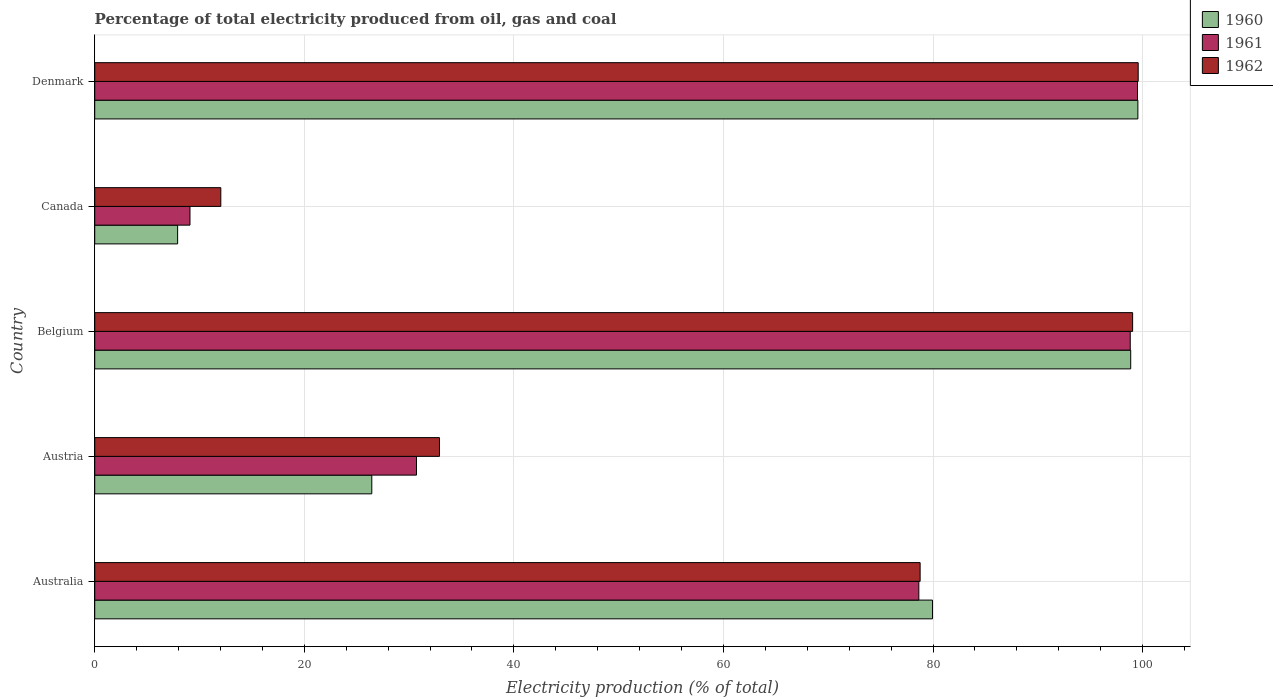How many different coloured bars are there?
Keep it short and to the point. 3. Are the number of bars per tick equal to the number of legend labels?
Provide a succinct answer. Yes. How many bars are there on the 3rd tick from the bottom?
Offer a very short reply. 3. What is the label of the 2nd group of bars from the top?
Provide a succinct answer. Canada. In how many cases, is the number of bars for a given country not equal to the number of legend labels?
Ensure brevity in your answer.  0. What is the electricity production in in 1961 in Belgium?
Provide a short and direct response. 98.82. Across all countries, what is the maximum electricity production in in 1962?
Provide a short and direct response. 99.58. Across all countries, what is the minimum electricity production in in 1962?
Offer a very short reply. 12.03. What is the total electricity production in in 1961 in the graph?
Provide a short and direct response. 316.77. What is the difference between the electricity production in in 1960 in Australia and that in Belgium?
Ensure brevity in your answer.  -18.92. What is the difference between the electricity production in in 1962 in Canada and the electricity production in in 1961 in Belgium?
Ensure brevity in your answer.  -86.79. What is the average electricity production in in 1962 per country?
Your answer should be very brief. 64.47. What is the difference between the electricity production in in 1961 and electricity production in in 1962 in Denmark?
Ensure brevity in your answer.  -0.07. What is the ratio of the electricity production in in 1961 in Australia to that in Austria?
Offer a very short reply. 2.56. Is the difference between the electricity production in in 1961 in Austria and Canada greater than the difference between the electricity production in in 1962 in Austria and Canada?
Provide a short and direct response. Yes. What is the difference between the highest and the second highest electricity production in in 1961?
Offer a terse response. 0.69. What is the difference between the highest and the lowest electricity production in in 1962?
Your answer should be compact. 87.55. What does the 1st bar from the top in Denmark represents?
Keep it short and to the point. 1962. How many bars are there?
Offer a terse response. 15. Are all the bars in the graph horizontal?
Your response must be concise. Yes. How many countries are there in the graph?
Your answer should be compact. 5. What is the difference between two consecutive major ticks on the X-axis?
Give a very brief answer. 20. Are the values on the major ticks of X-axis written in scientific E-notation?
Offer a very short reply. No. Does the graph contain grids?
Offer a very short reply. Yes. How many legend labels are there?
Ensure brevity in your answer.  3. How are the legend labels stacked?
Provide a succinct answer. Vertical. What is the title of the graph?
Your answer should be compact. Percentage of total electricity produced from oil, gas and coal. Does "1991" appear as one of the legend labels in the graph?
Offer a terse response. No. What is the label or title of the X-axis?
Keep it short and to the point. Electricity production (% of total). What is the Electricity production (% of total) in 1960 in Australia?
Offer a terse response. 79.95. What is the Electricity production (% of total) of 1961 in Australia?
Offer a very short reply. 78.65. What is the Electricity production (% of total) of 1962 in Australia?
Make the answer very short. 78.77. What is the Electricity production (% of total) of 1960 in Austria?
Offer a terse response. 26.44. What is the Electricity production (% of total) of 1961 in Austria?
Your answer should be very brief. 30.71. What is the Electricity production (% of total) in 1962 in Austria?
Provide a succinct answer. 32.9. What is the Electricity production (% of total) of 1960 in Belgium?
Your response must be concise. 98.86. What is the Electricity production (% of total) of 1961 in Belgium?
Your response must be concise. 98.82. What is the Electricity production (% of total) in 1962 in Belgium?
Offer a terse response. 99.05. What is the Electricity production (% of total) of 1960 in Canada?
Your answer should be compact. 7.91. What is the Electricity production (% of total) in 1961 in Canada?
Your answer should be very brief. 9.09. What is the Electricity production (% of total) of 1962 in Canada?
Your answer should be very brief. 12.03. What is the Electricity production (% of total) of 1960 in Denmark?
Provide a short and direct response. 99.55. What is the Electricity production (% of total) in 1961 in Denmark?
Offer a terse response. 99.51. What is the Electricity production (% of total) in 1962 in Denmark?
Give a very brief answer. 99.58. Across all countries, what is the maximum Electricity production (% of total) in 1960?
Offer a very short reply. 99.55. Across all countries, what is the maximum Electricity production (% of total) in 1961?
Give a very brief answer. 99.51. Across all countries, what is the maximum Electricity production (% of total) of 1962?
Your answer should be compact. 99.58. Across all countries, what is the minimum Electricity production (% of total) in 1960?
Your answer should be compact. 7.91. Across all countries, what is the minimum Electricity production (% of total) of 1961?
Offer a very short reply. 9.09. Across all countries, what is the minimum Electricity production (% of total) of 1962?
Make the answer very short. 12.03. What is the total Electricity production (% of total) of 1960 in the graph?
Your answer should be compact. 312.71. What is the total Electricity production (% of total) of 1961 in the graph?
Provide a succinct answer. 316.77. What is the total Electricity production (% of total) of 1962 in the graph?
Provide a short and direct response. 322.33. What is the difference between the Electricity production (% of total) of 1960 in Australia and that in Austria?
Offer a very short reply. 53.51. What is the difference between the Electricity production (% of total) of 1961 in Australia and that in Austria?
Provide a short and direct response. 47.94. What is the difference between the Electricity production (% of total) in 1962 in Australia and that in Austria?
Your answer should be very brief. 45.87. What is the difference between the Electricity production (% of total) in 1960 in Australia and that in Belgium?
Provide a short and direct response. -18.92. What is the difference between the Electricity production (% of total) of 1961 in Australia and that in Belgium?
Your answer should be very brief. -20.18. What is the difference between the Electricity production (% of total) of 1962 in Australia and that in Belgium?
Provide a succinct answer. -20.28. What is the difference between the Electricity production (% of total) in 1960 in Australia and that in Canada?
Ensure brevity in your answer.  72.04. What is the difference between the Electricity production (% of total) in 1961 in Australia and that in Canada?
Offer a very short reply. 69.56. What is the difference between the Electricity production (% of total) in 1962 in Australia and that in Canada?
Keep it short and to the point. 66.74. What is the difference between the Electricity production (% of total) of 1960 in Australia and that in Denmark?
Provide a succinct answer. -19.6. What is the difference between the Electricity production (% of total) of 1961 in Australia and that in Denmark?
Your answer should be compact. -20.87. What is the difference between the Electricity production (% of total) of 1962 in Australia and that in Denmark?
Offer a terse response. -20.81. What is the difference between the Electricity production (% of total) of 1960 in Austria and that in Belgium?
Offer a terse response. -72.42. What is the difference between the Electricity production (% of total) of 1961 in Austria and that in Belgium?
Give a very brief answer. -68.11. What is the difference between the Electricity production (% of total) of 1962 in Austria and that in Belgium?
Your answer should be very brief. -66.15. What is the difference between the Electricity production (% of total) in 1960 in Austria and that in Canada?
Make the answer very short. 18.53. What is the difference between the Electricity production (% of total) of 1961 in Austria and that in Canada?
Your response must be concise. 21.62. What is the difference between the Electricity production (% of total) in 1962 in Austria and that in Canada?
Your answer should be very brief. 20.87. What is the difference between the Electricity production (% of total) of 1960 in Austria and that in Denmark?
Your answer should be compact. -73.11. What is the difference between the Electricity production (% of total) in 1961 in Austria and that in Denmark?
Offer a terse response. -68.8. What is the difference between the Electricity production (% of total) of 1962 in Austria and that in Denmark?
Keep it short and to the point. -66.68. What is the difference between the Electricity production (% of total) in 1960 in Belgium and that in Canada?
Offer a very short reply. 90.95. What is the difference between the Electricity production (% of total) in 1961 in Belgium and that in Canada?
Keep it short and to the point. 89.73. What is the difference between the Electricity production (% of total) in 1962 in Belgium and that in Canada?
Keep it short and to the point. 87.02. What is the difference between the Electricity production (% of total) of 1960 in Belgium and that in Denmark?
Ensure brevity in your answer.  -0.68. What is the difference between the Electricity production (% of total) in 1961 in Belgium and that in Denmark?
Your response must be concise. -0.69. What is the difference between the Electricity production (% of total) of 1962 in Belgium and that in Denmark?
Offer a terse response. -0.53. What is the difference between the Electricity production (% of total) in 1960 in Canada and that in Denmark?
Make the answer very short. -91.64. What is the difference between the Electricity production (% of total) in 1961 in Canada and that in Denmark?
Offer a very short reply. -90.42. What is the difference between the Electricity production (% of total) in 1962 in Canada and that in Denmark?
Offer a very short reply. -87.55. What is the difference between the Electricity production (% of total) of 1960 in Australia and the Electricity production (% of total) of 1961 in Austria?
Your answer should be very brief. 49.24. What is the difference between the Electricity production (% of total) in 1960 in Australia and the Electricity production (% of total) in 1962 in Austria?
Offer a terse response. 47.05. What is the difference between the Electricity production (% of total) of 1961 in Australia and the Electricity production (% of total) of 1962 in Austria?
Provide a succinct answer. 45.74. What is the difference between the Electricity production (% of total) of 1960 in Australia and the Electricity production (% of total) of 1961 in Belgium?
Your answer should be compact. -18.87. What is the difference between the Electricity production (% of total) in 1960 in Australia and the Electricity production (% of total) in 1962 in Belgium?
Provide a succinct answer. -19.1. What is the difference between the Electricity production (% of total) of 1961 in Australia and the Electricity production (% of total) of 1962 in Belgium?
Make the answer very short. -20.4. What is the difference between the Electricity production (% of total) in 1960 in Australia and the Electricity production (% of total) in 1961 in Canada?
Offer a very short reply. 70.86. What is the difference between the Electricity production (% of total) in 1960 in Australia and the Electricity production (% of total) in 1962 in Canada?
Give a very brief answer. 67.92. What is the difference between the Electricity production (% of total) of 1961 in Australia and the Electricity production (% of total) of 1962 in Canada?
Your answer should be very brief. 66.61. What is the difference between the Electricity production (% of total) of 1960 in Australia and the Electricity production (% of total) of 1961 in Denmark?
Your answer should be very brief. -19.56. What is the difference between the Electricity production (% of total) in 1960 in Australia and the Electricity production (% of total) in 1962 in Denmark?
Give a very brief answer. -19.63. What is the difference between the Electricity production (% of total) of 1961 in Australia and the Electricity production (% of total) of 1962 in Denmark?
Your answer should be very brief. -20.93. What is the difference between the Electricity production (% of total) of 1960 in Austria and the Electricity production (% of total) of 1961 in Belgium?
Ensure brevity in your answer.  -72.38. What is the difference between the Electricity production (% of total) of 1960 in Austria and the Electricity production (% of total) of 1962 in Belgium?
Your answer should be compact. -72.61. What is the difference between the Electricity production (% of total) in 1961 in Austria and the Electricity production (% of total) in 1962 in Belgium?
Provide a succinct answer. -68.34. What is the difference between the Electricity production (% of total) in 1960 in Austria and the Electricity production (% of total) in 1961 in Canada?
Keep it short and to the point. 17.35. What is the difference between the Electricity production (% of total) of 1960 in Austria and the Electricity production (% of total) of 1962 in Canada?
Ensure brevity in your answer.  14.41. What is the difference between the Electricity production (% of total) in 1961 in Austria and the Electricity production (% of total) in 1962 in Canada?
Give a very brief answer. 18.67. What is the difference between the Electricity production (% of total) in 1960 in Austria and the Electricity production (% of total) in 1961 in Denmark?
Make the answer very short. -73.07. What is the difference between the Electricity production (% of total) of 1960 in Austria and the Electricity production (% of total) of 1962 in Denmark?
Your answer should be very brief. -73.14. What is the difference between the Electricity production (% of total) in 1961 in Austria and the Electricity production (% of total) in 1962 in Denmark?
Your response must be concise. -68.87. What is the difference between the Electricity production (% of total) of 1960 in Belgium and the Electricity production (% of total) of 1961 in Canada?
Provide a short and direct response. 89.78. What is the difference between the Electricity production (% of total) of 1960 in Belgium and the Electricity production (% of total) of 1962 in Canada?
Make the answer very short. 86.83. What is the difference between the Electricity production (% of total) in 1961 in Belgium and the Electricity production (% of total) in 1962 in Canada?
Give a very brief answer. 86.79. What is the difference between the Electricity production (% of total) of 1960 in Belgium and the Electricity production (% of total) of 1961 in Denmark?
Provide a short and direct response. -0.65. What is the difference between the Electricity production (% of total) in 1960 in Belgium and the Electricity production (% of total) in 1962 in Denmark?
Give a very brief answer. -0.71. What is the difference between the Electricity production (% of total) in 1961 in Belgium and the Electricity production (% of total) in 1962 in Denmark?
Give a very brief answer. -0.76. What is the difference between the Electricity production (% of total) in 1960 in Canada and the Electricity production (% of total) in 1961 in Denmark?
Ensure brevity in your answer.  -91.6. What is the difference between the Electricity production (% of total) in 1960 in Canada and the Electricity production (% of total) in 1962 in Denmark?
Provide a short and direct response. -91.67. What is the difference between the Electricity production (% of total) of 1961 in Canada and the Electricity production (% of total) of 1962 in Denmark?
Provide a succinct answer. -90.49. What is the average Electricity production (% of total) in 1960 per country?
Your response must be concise. 62.54. What is the average Electricity production (% of total) in 1961 per country?
Provide a short and direct response. 63.35. What is the average Electricity production (% of total) of 1962 per country?
Offer a terse response. 64.47. What is the difference between the Electricity production (% of total) in 1960 and Electricity production (% of total) in 1961 in Australia?
Provide a succinct answer. 1.3. What is the difference between the Electricity production (% of total) in 1960 and Electricity production (% of total) in 1962 in Australia?
Provide a short and direct response. 1.18. What is the difference between the Electricity production (% of total) of 1961 and Electricity production (% of total) of 1962 in Australia?
Ensure brevity in your answer.  -0.12. What is the difference between the Electricity production (% of total) in 1960 and Electricity production (% of total) in 1961 in Austria?
Provide a succinct answer. -4.27. What is the difference between the Electricity production (% of total) in 1960 and Electricity production (% of total) in 1962 in Austria?
Keep it short and to the point. -6.46. What is the difference between the Electricity production (% of total) in 1961 and Electricity production (% of total) in 1962 in Austria?
Your response must be concise. -2.19. What is the difference between the Electricity production (% of total) of 1960 and Electricity production (% of total) of 1961 in Belgium?
Offer a terse response. 0.04. What is the difference between the Electricity production (% of total) of 1960 and Electricity production (% of total) of 1962 in Belgium?
Ensure brevity in your answer.  -0.18. What is the difference between the Electricity production (% of total) in 1961 and Electricity production (% of total) in 1962 in Belgium?
Provide a succinct answer. -0.23. What is the difference between the Electricity production (% of total) of 1960 and Electricity production (% of total) of 1961 in Canada?
Your response must be concise. -1.18. What is the difference between the Electricity production (% of total) in 1960 and Electricity production (% of total) in 1962 in Canada?
Provide a short and direct response. -4.12. What is the difference between the Electricity production (% of total) of 1961 and Electricity production (% of total) of 1962 in Canada?
Your answer should be compact. -2.94. What is the difference between the Electricity production (% of total) of 1960 and Electricity production (% of total) of 1961 in Denmark?
Offer a terse response. 0.04. What is the difference between the Electricity production (% of total) of 1960 and Electricity production (% of total) of 1962 in Denmark?
Provide a short and direct response. -0.03. What is the difference between the Electricity production (% of total) in 1961 and Electricity production (% of total) in 1962 in Denmark?
Provide a short and direct response. -0.07. What is the ratio of the Electricity production (% of total) in 1960 in Australia to that in Austria?
Offer a very short reply. 3.02. What is the ratio of the Electricity production (% of total) in 1961 in Australia to that in Austria?
Offer a terse response. 2.56. What is the ratio of the Electricity production (% of total) of 1962 in Australia to that in Austria?
Your answer should be very brief. 2.39. What is the ratio of the Electricity production (% of total) of 1960 in Australia to that in Belgium?
Make the answer very short. 0.81. What is the ratio of the Electricity production (% of total) of 1961 in Australia to that in Belgium?
Provide a short and direct response. 0.8. What is the ratio of the Electricity production (% of total) of 1962 in Australia to that in Belgium?
Your answer should be very brief. 0.8. What is the ratio of the Electricity production (% of total) in 1960 in Australia to that in Canada?
Provide a short and direct response. 10.11. What is the ratio of the Electricity production (% of total) in 1961 in Australia to that in Canada?
Give a very brief answer. 8.65. What is the ratio of the Electricity production (% of total) in 1962 in Australia to that in Canada?
Your answer should be very brief. 6.55. What is the ratio of the Electricity production (% of total) of 1960 in Australia to that in Denmark?
Keep it short and to the point. 0.8. What is the ratio of the Electricity production (% of total) of 1961 in Australia to that in Denmark?
Your response must be concise. 0.79. What is the ratio of the Electricity production (% of total) of 1962 in Australia to that in Denmark?
Ensure brevity in your answer.  0.79. What is the ratio of the Electricity production (% of total) in 1960 in Austria to that in Belgium?
Ensure brevity in your answer.  0.27. What is the ratio of the Electricity production (% of total) in 1961 in Austria to that in Belgium?
Offer a terse response. 0.31. What is the ratio of the Electricity production (% of total) in 1962 in Austria to that in Belgium?
Offer a very short reply. 0.33. What is the ratio of the Electricity production (% of total) in 1960 in Austria to that in Canada?
Your answer should be very brief. 3.34. What is the ratio of the Electricity production (% of total) in 1961 in Austria to that in Canada?
Your answer should be very brief. 3.38. What is the ratio of the Electricity production (% of total) of 1962 in Austria to that in Canada?
Your answer should be very brief. 2.73. What is the ratio of the Electricity production (% of total) of 1960 in Austria to that in Denmark?
Your answer should be compact. 0.27. What is the ratio of the Electricity production (% of total) in 1961 in Austria to that in Denmark?
Your answer should be very brief. 0.31. What is the ratio of the Electricity production (% of total) in 1962 in Austria to that in Denmark?
Your answer should be very brief. 0.33. What is the ratio of the Electricity production (% of total) in 1960 in Belgium to that in Canada?
Your answer should be very brief. 12.5. What is the ratio of the Electricity production (% of total) in 1961 in Belgium to that in Canada?
Ensure brevity in your answer.  10.87. What is the ratio of the Electricity production (% of total) of 1962 in Belgium to that in Canada?
Provide a succinct answer. 8.23. What is the ratio of the Electricity production (% of total) in 1960 in Belgium to that in Denmark?
Your answer should be compact. 0.99. What is the ratio of the Electricity production (% of total) in 1961 in Belgium to that in Denmark?
Provide a short and direct response. 0.99. What is the ratio of the Electricity production (% of total) in 1960 in Canada to that in Denmark?
Provide a short and direct response. 0.08. What is the ratio of the Electricity production (% of total) of 1961 in Canada to that in Denmark?
Your answer should be very brief. 0.09. What is the ratio of the Electricity production (% of total) in 1962 in Canada to that in Denmark?
Your answer should be very brief. 0.12. What is the difference between the highest and the second highest Electricity production (% of total) in 1960?
Provide a short and direct response. 0.68. What is the difference between the highest and the second highest Electricity production (% of total) in 1961?
Make the answer very short. 0.69. What is the difference between the highest and the second highest Electricity production (% of total) in 1962?
Provide a succinct answer. 0.53. What is the difference between the highest and the lowest Electricity production (% of total) in 1960?
Provide a short and direct response. 91.64. What is the difference between the highest and the lowest Electricity production (% of total) of 1961?
Offer a very short reply. 90.42. What is the difference between the highest and the lowest Electricity production (% of total) in 1962?
Make the answer very short. 87.55. 